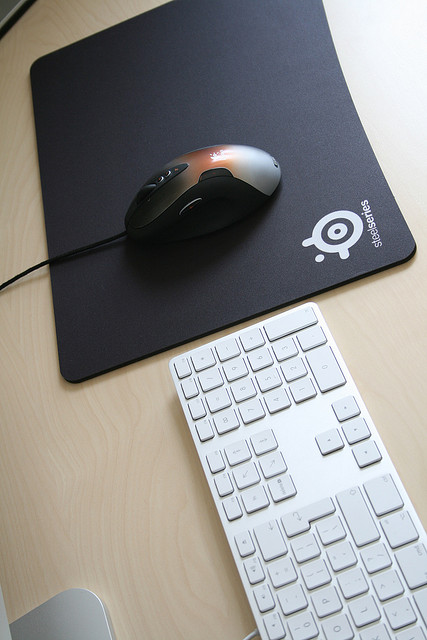Identify the text displayed in this image. STEELSERIES 